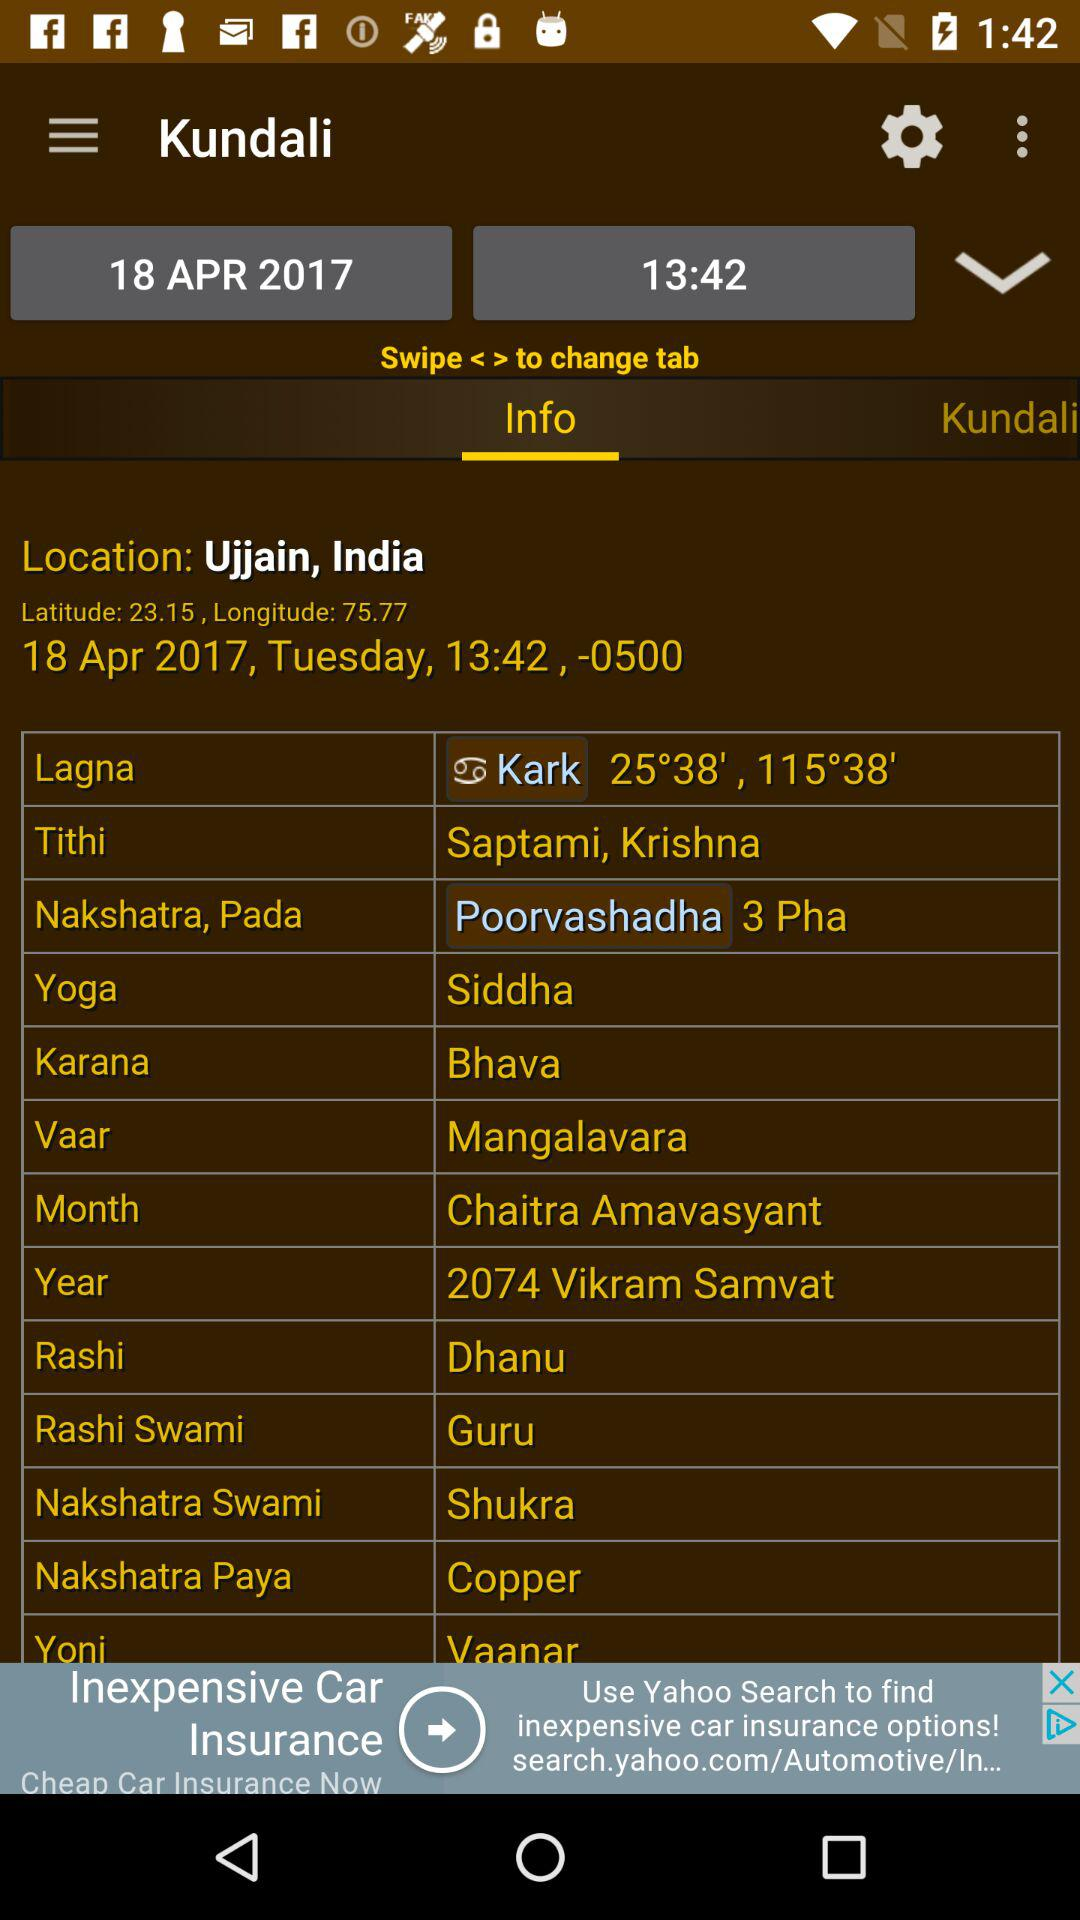What is the selected date? The selected date is April 18, 2017. 